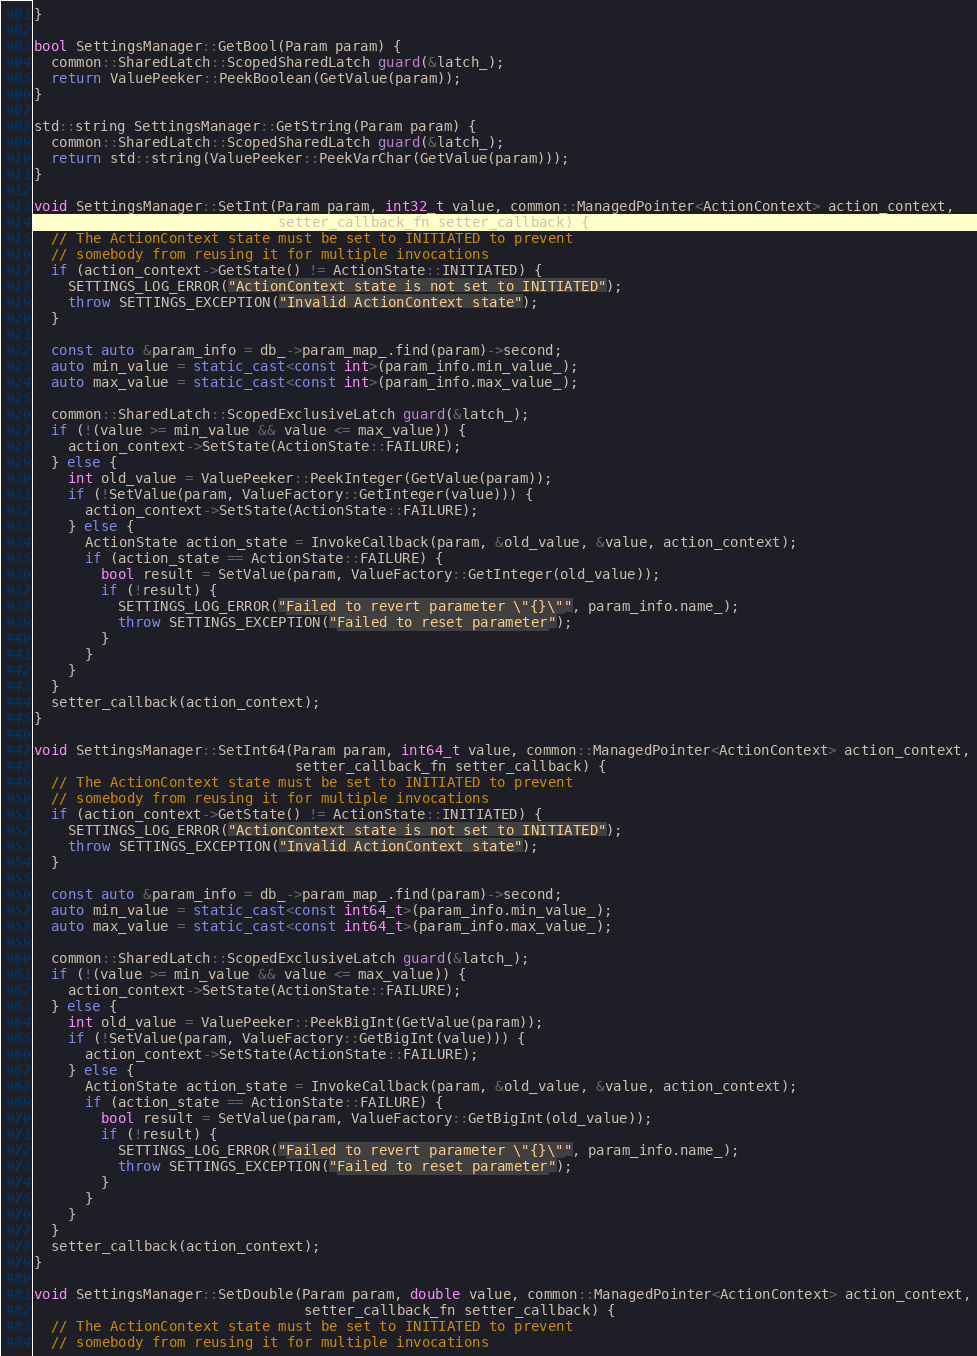<code> <loc_0><loc_0><loc_500><loc_500><_C++_>}

bool SettingsManager::GetBool(Param param) {
  common::SharedLatch::ScopedSharedLatch guard(&latch_);
  return ValuePeeker::PeekBoolean(GetValue(param));
}

std::string SettingsManager::GetString(Param param) {
  common::SharedLatch::ScopedSharedLatch guard(&latch_);
  return std::string(ValuePeeker::PeekVarChar(GetValue(param)));
}

void SettingsManager::SetInt(Param param, int32_t value, common::ManagedPointer<ActionContext> action_context,
                             setter_callback_fn setter_callback) {
  // The ActionContext state must be set to INITIATED to prevent
  // somebody from reusing it for multiple invocations
  if (action_context->GetState() != ActionState::INITIATED) {
    SETTINGS_LOG_ERROR("ActionContext state is not set to INITIATED");
    throw SETTINGS_EXCEPTION("Invalid ActionContext state");
  }

  const auto &param_info = db_->param_map_.find(param)->second;
  auto min_value = static_cast<const int>(param_info.min_value_);
  auto max_value = static_cast<const int>(param_info.max_value_);

  common::SharedLatch::ScopedExclusiveLatch guard(&latch_);
  if (!(value >= min_value && value <= max_value)) {
    action_context->SetState(ActionState::FAILURE);
  } else {
    int old_value = ValuePeeker::PeekInteger(GetValue(param));
    if (!SetValue(param, ValueFactory::GetInteger(value))) {
      action_context->SetState(ActionState::FAILURE);
    } else {
      ActionState action_state = InvokeCallback(param, &old_value, &value, action_context);
      if (action_state == ActionState::FAILURE) {
        bool result = SetValue(param, ValueFactory::GetInteger(old_value));
        if (!result) {
          SETTINGS_LOG_ERROR("Failed to revert parameter \"{}\"", param_info.name_);
          throw SETTINGS_EXCEPTION("Failed to reset parameter");
        }
      }
    }
  }
  setter_callback(action_context);
}

void SettingsManager::SetInt64(Param param, int64_t value, common::ManagedPointer<ActionContext> action_context,
                               setter_callback_fn setter_callback) {
  // The ActionContext state must be set to INITIATED to prevent
  // somebody from reusing it for multiple invocations
  if (action_context->GetState() != ActionState::INITIATED) {
    SETTINGS_LOG_ERROR("ActionContext state is not set to INITIATED");
    throw SETTINGS_EXCEPTION("Invalid ActionContext state");
  }

  const auto &param_info = db_->param_map_.find(param)->second;
  auto min_value = static_cast<const int64_t>(param_info.min_value_);
  auto max_value = static_cast<const int64_t>(param_info.max_value_);

  common::SharedLatch::ScopedExclusiveLatch guard(&latch_);
  if (!(value >= min_value && value <= max_value)) {
    action_context->SetState(ActionState::FAILURE);
  } else {
    int old_value = ValuePeeker::PeekBigInt(GetValue(param));
    if (!SetValue(param, ValueFactory::GetBigInt(value))) {
      action_context->SetState(ActionState::FAILURE);
    } else {
      ActionState action_state = InvokeCallback(param, &old_value, &value, action_context);
      if (action_state == ActionState::FAILURE) {
        bool result = SetValue(param, ValueFactory::GetBigInt(old_value));
        if (!result) {
          SETTINGS_LOG_ERROR("Failed to revert parameter \"{}\"", param_info.name_);
          throw SETTINGS_EXCEPTION("Failed to reset parameter");
        }
      }
    }
  }
  setter_callback(action_context);
}

void SettingsManager::SetDouble(Param param, double value, common::ManagedPointer<ActionContext> action_context,
                                setter_callback_fn setter_callback) {
  // The ActionContext state must be set to INITIATED to prevent
  // somebody from reusing it for multiple invocations</code> 